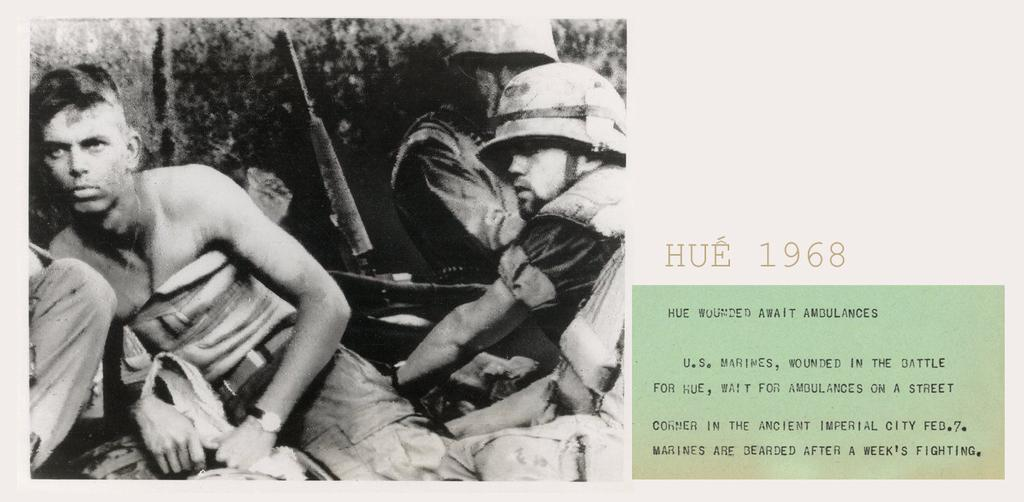Who is present in the image? There are men in the image. What is the color scheme of the image? The image is in black and white. Where is the text located in the image? The text is on the right side of the image. What type of paste is being used by the goose in the image? There is no goose or paste present in the image. How many cakes are visible in the image? There are no cakes visible in the image. 